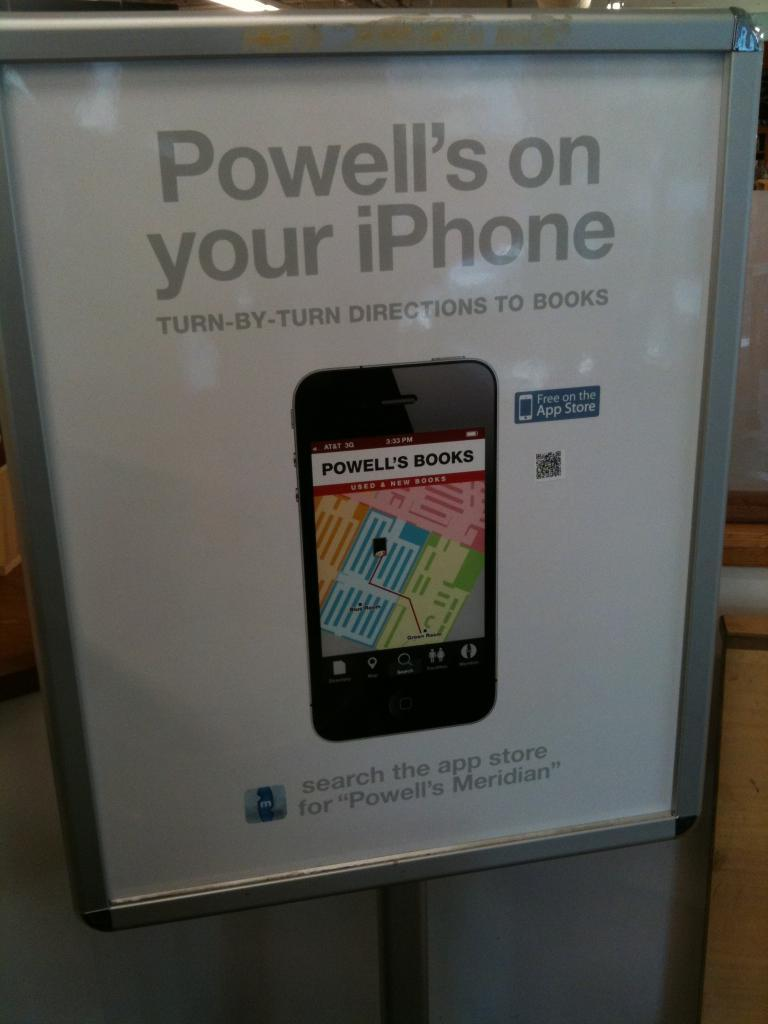<image>
Present a compact description of the photo's key features. An advertisement for Powell's Books showing how to get directions on your iPhone. 